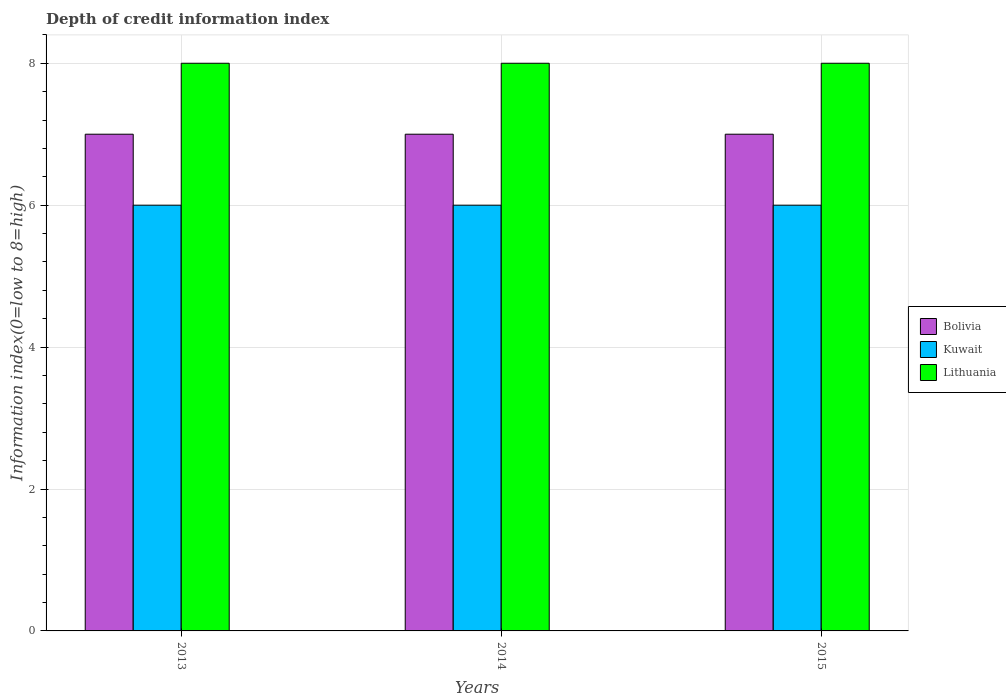How many different coloured bars are there?
Your answer should be compact. 3. How many bars are there on the 1st tick from the left?
Your response must be concise. 3. What is the label of the 2nd group of bars from the left?
Offer a terse response. 2014. In how many cases, is the number of bars for a given year not equal to the number of legend labels?
Make the answer very short. 0. What is the information index in Bolivia in 2014?
Give a very brief answer. 7. Across all years, what is the maximum information index in Bolivia?
Give a very brief answer. 7. Across all years, what is the minimum information index in Kuwait?
Your response must be concise. 6. In which year was the information index in Lithuania minimum?
Your response must be concise. 2013. What is the total information index in Bolivia in the graph?
Offer a terse response. 21. What is the difference between the information index in Kuwait in 2013 and that in 2015?
Make the answer very short. 0. What is the difference between the information index in Kuwait in 2014 and the information index in Bolivia in 2013?
Provide a succinct answer. -1. In the year 2013, what is the difference between the information index in Bolivia and information index in Lithuania?
Your answer should be compact. -1. In how many years, is the information index in Bolivia greater than 2.4?
Your answer should be very brief. 3. What is the ratio of the information index in Kuwait in 2013 to that in 2015?
Your answer should be compact. 1. Is the information index in Bolivia in 2013 less than that in 2015?
Your answer should be compact. No. In how many years, is the information index in Kuwait greater than the average information index in Kuwait taken over all years?
Provide a succinct answer. 0. What does the 1st bar from the left in 2014 represents?
Offer a terse response. Bolivia. What does the 1st bar from the right in 2015 represents?
Offer a very short reply. Lithuania. How many bars are there?
Your answer should be very brief. 9. Are all the bars in the graph horizontal?
Make the answer very short. No. Does the graph contain any zero values?
Provide a succinct answer. No. Where does the legend appear in the graph?
Ensure brevity in your answer.  Center right. How are the legend labels stacked?
Offer a terse response. Vertical. What is the title of the graph?
Make the answer very short. Depth of credit information index. Does "Nigeria" appear as one of the legend labels in the graph?
Keep it short and to the point. No. What is the label or title of the X-axis?
Your answer should be very brief. Years. What is the label or title of the Y-axis?
Your answer should be compact. Information index(0=low to 8=high). What is the Information index(0=low to 8=high) in Bolivia in 2013?
Ensure brevity in your answer.  7. What is the Information index(0=low to 8=high) of Kuwait in 2013?
Your answer should be very brief. 6. What is the Information index(0=low to 8=high) of Lithuania in 2013?
Offer a terse response. 8. What is the Information index(0=low to 8=high) in Bolivia in 2014?
Keep it short and to the point. 7. What is the Information index(0=low to 8=high) of Kuwait in 2014?
Your response must be concise. 6. What is the Information index(0=low to 8=high) in Lithuania in 2014?
Make the answer very short. 8. What is the Information index(0=low to 8=high) of Lithuania in 2015?
Provide a short and direct response. 8. Across all years, what is the maximum Information index(0=low to 8=high) in Kuwait?
Offer a terse response. 6. Across all years, what is the maximum Information index(0=low to 8=high) of Lithuania?
Your response must be concise. 8. Across all years, what is the minimum Information index(0=low to 8=high) of Bolivia?
Make the answer very short. 7. What is the total Information index(0=low to 8=high) of Kuwait in the graph?
Give a very brief answer. 18. What is the difference between the Information index(0=low to 8=high) in Bolivia in 2013 and that in 2014?
Offer a terse response. 0. What is the difference between the Information index(0=low to 8=high) in Kuwait in 2013 and that in 2014?
Your response must be concise. 0. What is the difference between the Information index(0=low to 8=high) in Bolivia in 2013 and that in 2015?
Ensure brevity in your answer.  0. What is the difference between the Information index(0=low to 8=high) of Kuwait in 2013 and that in 2015?
Make the answer very short. 0. What is the difference between the Information index(0=low to 8=high) of Lithuania in 2013 and that in 2015?
Ensure brevity in your answer.  0. What is the difference between the Information index(0=low to 8=high) of Kuwait in 2014 and that in 2015?
Keep it short and to the point. 0. What is the difference between the Information index(0=low to 8=high) of Lithuania in 2014 and that in 2015?
Make the answer very short. 0. What is the difference between the Information index(0=low to 8=high) of Bolivia in 2013 and the Information index(0=low to 8=high) of Kuwait in 2015?
Your answer should be compact. 1. What is the difference between the Information index(0=low to 8=high) of Bolivia in 2013 and the Information index(0=low to 8=high) of Lithuania in 2015?
Provide a succinct answer. -1. What is the difference between the Information index(0=low to 8=high) of Bolivia in 2014 and the Information index(0=low to 8=high) of Kuwait in 2015?
Give a very brief answer. 1. What is the difference between the Information index(0=low to 8=high) in Kuwait in 2014 and the Information index(0=low to 8=high) in Lithuania in 2015?
Your response must be concise. -2. What is the average Information index(0=low to 8=high) in Bolivia per year?
Your response must be concise. 7. What is the average Information index(0=low to 8=high) in Lithuania per year?
Keep it short and to the point. 8. In the year 2013, what is the difference between the Information index(0=low to 8=high) of Bolivia and Information index(0=low to 8=high) of Lithuania?
Your response must be concise. -1. In the year 2014, what is the difference between the Information index(0=low to 8=high) in Bolivia and Information index(0=low to 8=high) in Kuwait?
Ensure brevity in your answer.  1. In the year 2014, what is the difference between the Information index(0=low to 8=high) in Bolivia and Information index(0=low to 8=high) in Lithuania?
Provide a succinct answer. -1. In the year 2014, what is the difference between the Information index(0=low to 8=high) of Kuwait and Information index(0=low to 8=high) of Lithuania?
Provide a succinct answer. -2. In the year 2015, what is the difference between the Information index(0=low to 8=high) in Bolivia and Information index(0=low to 8=high) in Lithuania?
Make the answer very short. -1. In the year 2015, what is the difference between the Information index(0=low to 8=high) in Kuwait and Information index(0=low to 8=high) in Lithuania?
Give a very brief answer. -2. What is the ratio of the Information index(0=low to 8=high) of Bolivia in 2013 to that in 2014?
Give a very brief answer. 1. What is the ratio of the Information index(0=low to 8=high) in Lithuania in 2013 to that in 2014?
Give a very brief answer. 1. What is the ratio of the Information index(0=low to 8=high) of Bolivia in 2013 to that in 2015?
Your answer should be compact. 1. What is the ratio of the Information index(0=low to 8=high) in Kuwait in 2013 to that in 2015?
Give a very brief answer. 1. What is the ratio of the Information index(0=low to 8=high) in Bolivia in 2014 to that in 2015?
Keep it short and to the point. 1. What is the ratio of the Information index(0=low to 8=high) of Lithuania in 2014 to that in 2015?
Ensure brevity in your answer.  1. What is the difference between the highest and the second highest Information index(0=low to 8=high) of Kuwait?
Your answer should be compact. 0. What is the difference between the highest and the lowest Information index(0=low to 8=high) of Bolivia?
Offer a very short reply. 0. What is the difference between the highest and the lowest Information index(0=low to 8=high) in Kuwait?
Ensure brevity in your answer.  0. What is the difference between the highest and the lowest Information index(0=low to 8=high) of Lithuania?
Keep it short and to the point. 0. 